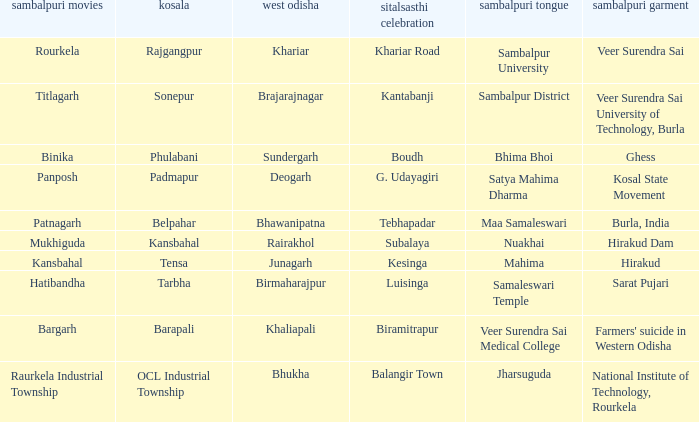Would you mind parsing the complete table? {'header': ['sambalpuri movies', 'kosala', 'west odisha', 'sitalsasthi celebration', 'sambalpuri tongue', 'sambalpuri garment'], 'rows': [['Rourkela', 'Rajgangpur', 'Khariar', 'Khariar Road', 'Sambalpur University', 'Veer Surendra Sai'], ['Titlagarh', 'Sonepur', 'Brajarajnagar', 'Kantabanji', 'Sambalpur District', 'Veer Surendra Sai University of Technology, Burla'], ['Binika', 'Phulabani', 'Sundergarh', 'Boudh', 'Bhima Bhoi', 'Ghess'], ['Panposh', 'Padmapur', 'Deogarh', 'G. Udayagiri', 'Satya Mahima Dharma', 'Kosal State Movement'], ['Patnagarh', 'Belpahar', 'Bhawanipatna', 'Tebhapadar', 'Maa Samaleswari', 'Burla, India'], ['Mukhiguda', 'Kansbahal', 'Rairakhol', 'Subalaya', 'Nuakhai', 'Hirakud Dam'], ['Kansbahal', 'Tensa', 'Junagarh', 'Kesinga', 'Mahima', 'Hirakud'], ['Hatibandha', 'Tarbha', 'Birmaharajpur', 'Luisinga', 'Samaleswari Temple', 'Sarat Pujari'], ['Bargarh', 'Barapali', 'Khaliapali', 'Biramitrapur', 'Veer Surendra Sai Medical College', "Farmers' suicide in Western Odisha"], ['Raurkela Industrial Township', 'OCL Industrial Township', 'Bhukha', 'Balangir Town', 'Jharsuguda', 'National Institute of Technology, Rourkela']]} What is the sitalsasthi carnival with hirakud as sambalpuri saree? Kesinga. 